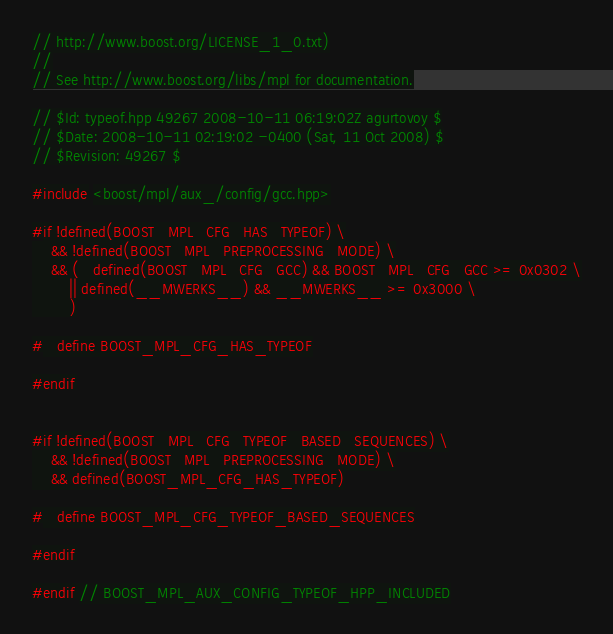<code> <loc_0><loc_0><loc_500><loc_500><_C++_>// http://www.boost.org/LICENSE_1_0.txt)
//
// See http://www.boost.org/libs/mpl for documentation.

// $Id: typeof.hpp 49267 2008-10-11 06:19:02Z agurtovoy $
// $Date: 2008-10-11 02:19:02 -0400 (Sat, 11 Oct 2008) $
// $Revision: 49267 $

#include <boost/mpl/aux_/config/gcc.hpp>

#if !defined(BOOST_MPL_CFG_HAS_TYPEOF) \
    && !defined(BOOST_MPL_PREPROCESSING_MODE) \
    && (   defined(BOOST_MPL_CFG_GCC) && BOOST_MPL_CFG_GCC >= 0x0302 \
        || defined(__MWERKS__) && __MWERKS__ >= 0x3000 \
        )

#   define BOOST_MPL_CFG_HAS_TYPEOF

#endif


#if !defined(BOOST_MPL_CFG_TYPEOF_BASED_SEQUENCES) \
    && !defined(BOOST_MPL_PREPROCESSING_MODE) \
    && defined(BOOST_MPL_CFG_HAS_TYPEOF)

#   define BOOST_MPL_CFG_TYPEOF_BASED_SEQUENCES

#endif

#endif // BOOST_MPL_AUX_CONFIG_TYPEOF_HPP_INCLUDED
</code> 